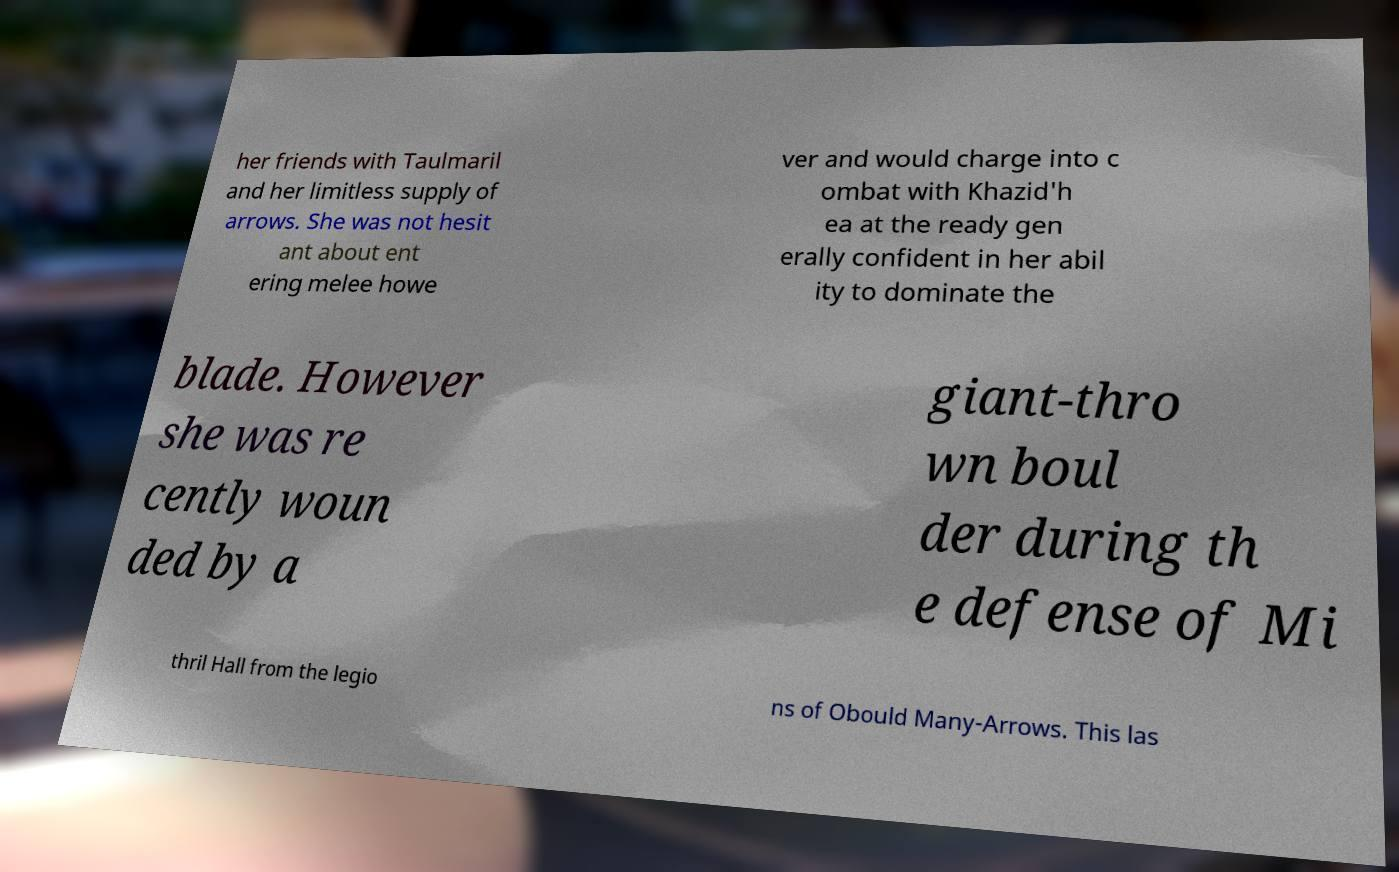Can you read and provide the text displayed in the image?This photo seems to have some interesting text. Can you extract and type it out for me? her friends with Taulmaril and her limitless supply of arrows. She was not hesit ant about ent ering melee howe ver and would charge into c ombat with Khazid'h ea at the ready gen erally confident in her abil ity to dominate the blade. However she was re cently woun ded by a giant-thro wn boul der during th e defense of Mi thril Hall from the legio ns of Obould Many-Arrows. This las 